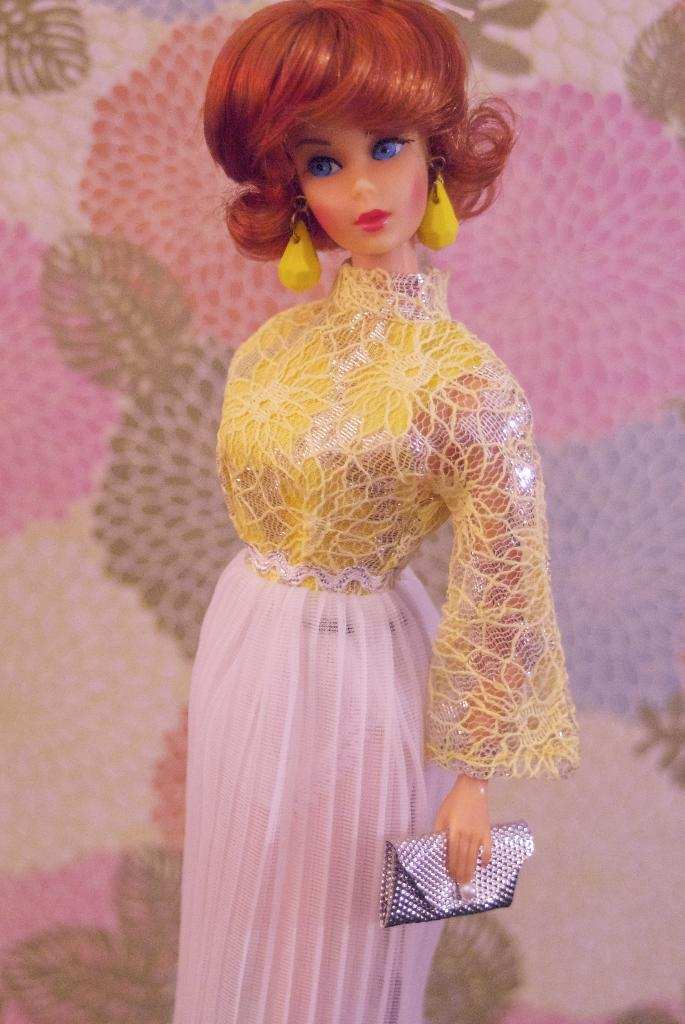What is the main subject of the image? There is a doll in the image. What is the doll wearing? The doll is wearing a dress and earrings. What is the doll holding? The doll is holding a wallet. Can you describe the background of the image? There is a pattern design in the background of the image. What is the weight of the wool in the image? There is no wool present in the image, so it is not possible to determine its weight. 